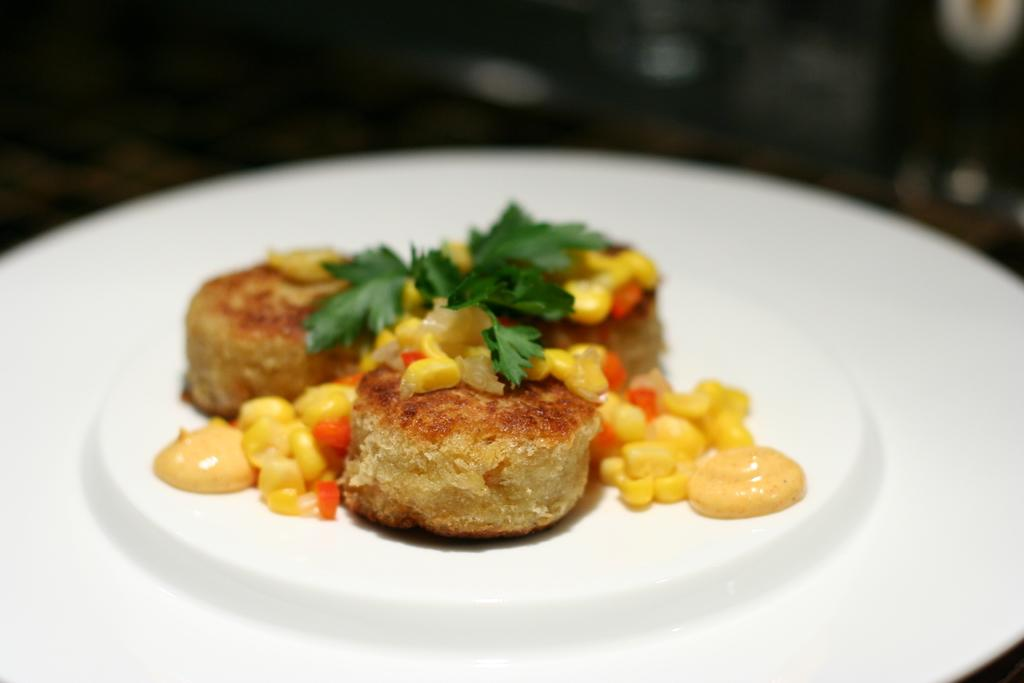What is on top of the cakes in the image? There are leaves on the cakes. What color is the plate that the cakes are on? The cakes are on a white color plate. What other items are present on the plate with the cakes? There are seeds and cream on the plate. How would you describe the background of the image? The background of the image is dark in color. What type of iron is being used to hold the cakes in the image? There is no iron present in the image; the cakes are on a plate. Can you see a kite flying in the background of the image? There is no kite visible in the image; the background is dark in color. 